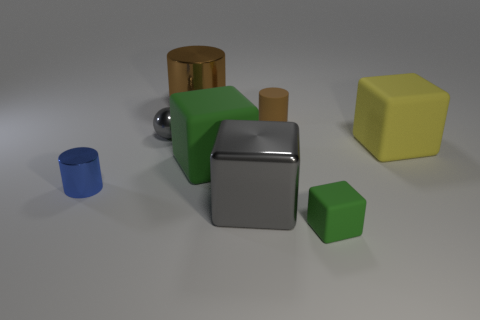Is the number of yellow things in front of the yellow block the same as the number of brown rubber things that are right of the metal sphere?
Provide a short and direct response. No. What is the color of the small cylinder that is the same material as the big brown cylinder?
Give a very brief answer. Blue. Does the metal sphere have the same color as the metal object that is right of the brown shiny cylinder?
Keep it short and to the point. Yes. Is there a small sphere that is behind the metal cylinder behind the small cylinder right of the large green rubber block?
Make the answer very short. No. There is a blue thing that is the same material as the large gray object; what shape is it?
Keep it short and to the point. Cylinder. Is there anything else that is the same shape as the large green rubber thing?
Ensure brevity in your answer.  Yes. What is the shape of the tiny gray object?
Provide a short and direct response. Sphere. Does the large shiny thing that is in front of the yellow rubber block have the same shape as the tiny gray object?
Provide a succinct answer. No. Are there more large brown objects right of the big yellow matte object than big matte blocks left of the large shiny block?
Make the answer very short. No. How many other objects are there of the same size as the yellow matte block?
Your response must be concise. 3. 